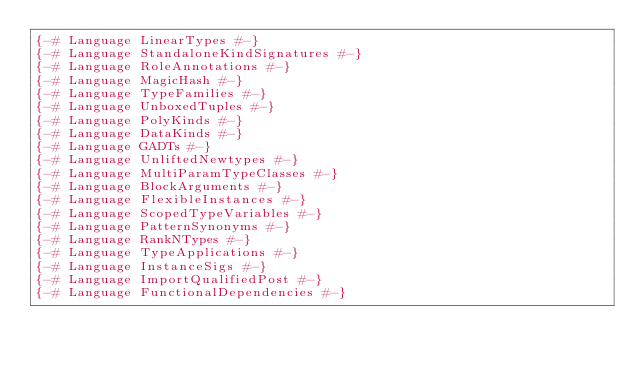<code> <loc_0><loc_0><loc_500><loc_500><_Haskell_>{-# Language LinearTypes #-}
{-# Language StandaloneKindSignatures #-}
{-# Language RoleAnnotations #-}
{-# Language MagicHash #-}
{-# Language TypeFamilies #-}
{-# Language UnboxedTuples #-}
{-# Language PolyKinds #-}
{-# Language DataKinds #-}
{-# Language GADTs #-}
{-# Language UnliftedNewtypes #-}
{-# Language MultiParamTypeClasses #-}
{-# Language BlockArguments #-}
{-# Language FlexibleInstances #-}
{-# Language ScopedTypeVariables #-}
{-# Language PatternSynonyms #-}
{-# Language RankNTypes #-}
{-# Language TypeApplications #-}
{-# Language InstanceSigs #-}
{-# Language ImportQualifiedPost #-}
{-# Language FunctionalDependencies #-}
</code> 